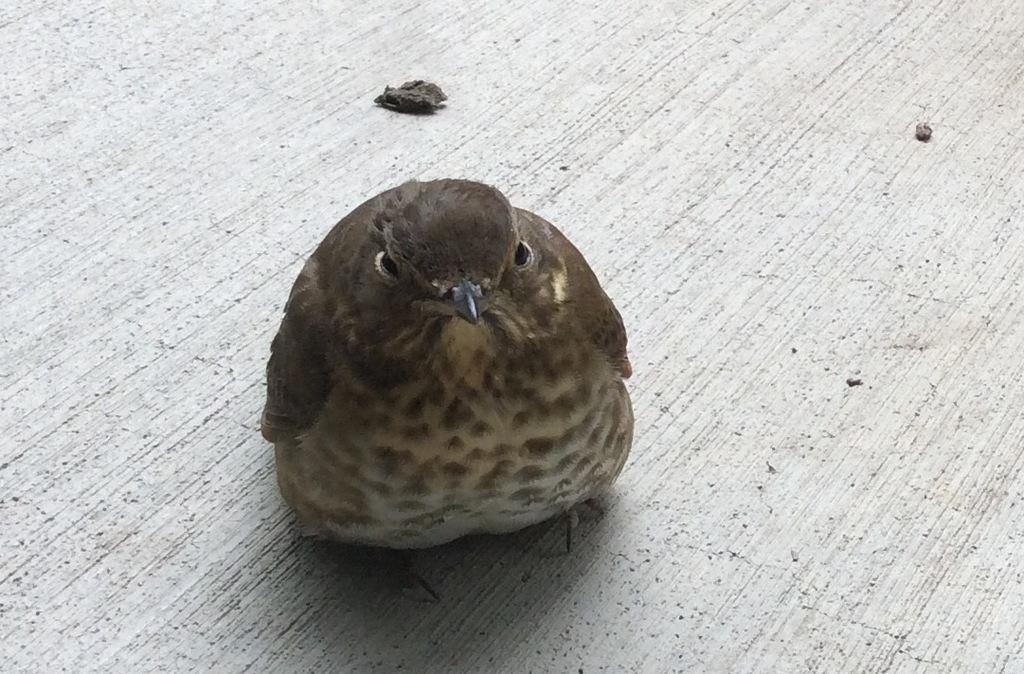Please provide a concise description of this image. In the center of the image we can see bird on the floor. 